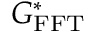<formula> <loc_0><loc_0><loc_500><loc_500>G _ { F F T } ^ { * }</formula> 